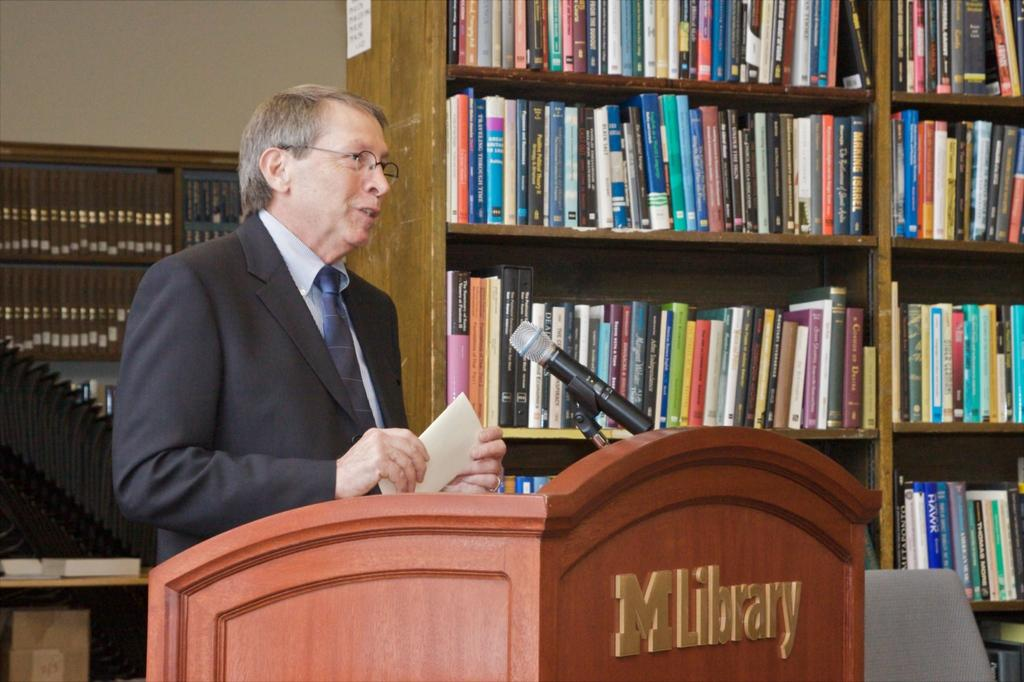<image>
Offer a succinct explanation of the picture presented. A man behind a podium that says MLibrary is making a speech. 